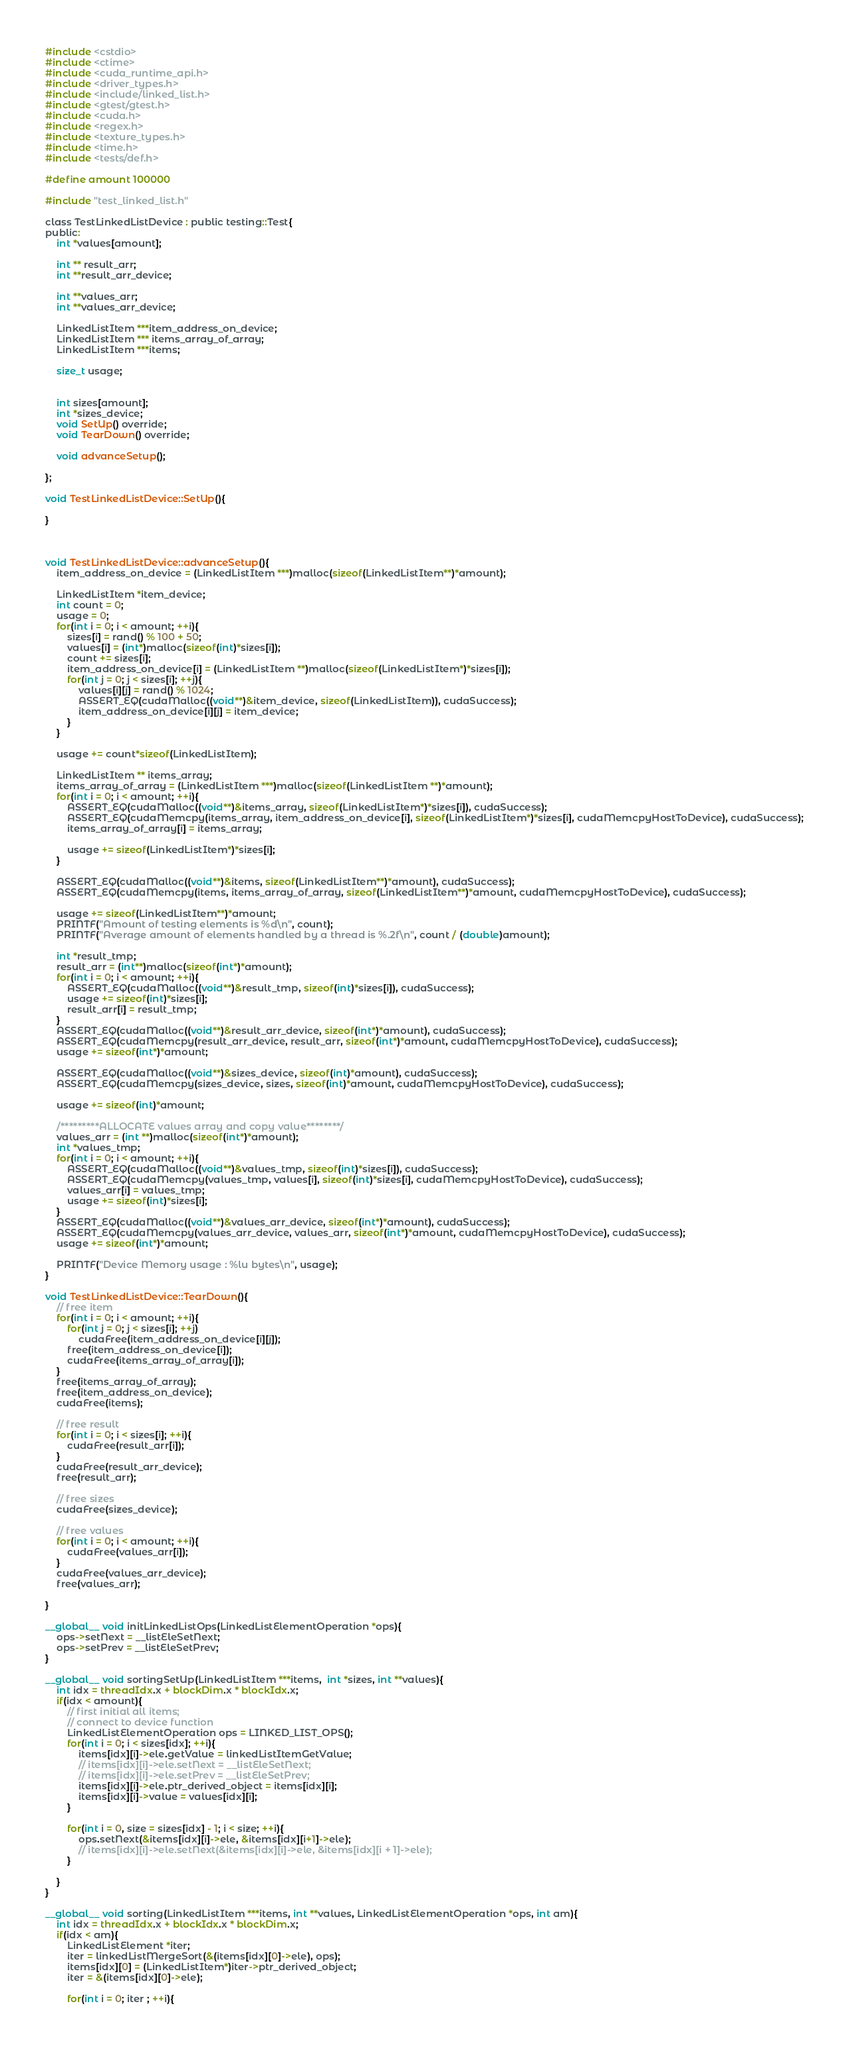<code> <loc_0><loc_0><loc_500><loc_500><_Cuda_>#include <cstdio>
#include <ctime>
#include <cuda_runtime_api.h>
#include <driver_types.h>
#include <include/linked_list.h>
#include <gtest/gtest.h>
#include <cuda.h>
#include <regex.h>
#include <texture_types.h>
#include <time.h>
#include <tests/def.h>

#define amount 100000

#include "test_linked_list.h"

class TestLinkedListDevice : public testing::Test{
public:
	int *values[amount];

	int ** result_arr;
	int **result_arr_device;

	int **values_arr;
	int **values_arr_device;

	LinkedListItem ***item_address_on_device;
	LinkedListItem *** items_array_of_array;
	LinkedListItem ***items;

	size_t usage;


	int sizes[amount];
	int *sizes_device;
	void SetUp() override;
	void TearDown() override;

	void advanceSetup();

};

void TestLinkedListDevice::SetUp(){

}



void TestLinkedListDevice::advanceSetup(){
	item_address_on_device = (LinkedListItem ***)malloc(sizeof(LinkedListItem**)*amount);	

	LinkedListItem *item_device;
	int count = 0;
	usage = 0;
	for(int i = 0; i < amount; ++i){
		sizes[i] = rand() % 100 + 50;
		values[i] = (int*)malloc(sizeof(int)*sizes[i]);
		count += sizes[i];
		item_address_on_device[i] = (LinkedListItem **)malloc(sizeof(LinkedListItem*)*sizes[i]);
		for(int j = 0; j < sizes[i]; ++j){
			values[i][j] = rand() % 1024;
			ASSERT_EQ(cudaMalloc((void**)&item_device, sizeof(LinkedListItem)), cudaSuccess);
			item_address_on_device[i][j] = item_device;
		}
	}
	
	usage += count*sizeof(LinkedListItem);
	
	LinkedListItem ** items_array;
	items_array_of_array = (LinkedListItem ***)malloc(sizeof(LinkedListItem **)*amount);
	for(int i = 0; i < amount; ++i){
		ASSERT_EQ(cudaMalloc((void**)&items_array, sizeof(LinkedListItem*)*sizes[i]), cudaSuccess);
		ASSERT_EQ(cudaMemcpy(items_array, item_address_on_device[i], sizeof(LinkedListItem*)*sizes[i], cudaMemcpyHostToDevice), cudaSuccess);
		items_array_of_array[i] = items_array;

		usage += sizeof(LinkedListItem*)*sizes[i];
	}

	ASSERT_EQ(cudaMalloc((void**)&items, sizeof(LinkedListItem**)*amount), cudaSuccess);
	ASSERT_EQ(cudaMemcpy(items, items_array_of_array, sizeof(LinkedListItem**)*amount, cudaMemcpyHostToDevice), cudaSuccess);

	usage += sizeof(LinkedListItem**)*amount;
	PRINTF("Amount of testing elements is %d\n", count);
	PRINTF("Average amount of elements handled by a thread is %.2f\n", count / (double)amount);

	int *result_tmp;
	result_arr = (int**)malloc(sizeof(int*)*amount);
	for(int i = 0; i < amount; ++i){
		ASSERT_EQ(cudaMalloc((void**)&result_tmp, sizeof(int)*sizes[i]), cudaSuccess);
		usage += sizeof(int)*sizes[i];
		result_arr[i] = result_tmp;
	}
	ASSERT_EQ(cudaMalloc((void**)&result_arr_device, sizeof(int*)*amount), cudaSuccess);
	ASSERT_EQ(cudaMemcpy(result_arr_device, result_arr, sizeof(int*)*amount, cudaMemcpyHostToDevice), cudaSuccess);
	usage += sizeof(int*)*amount;

	ASSERT_EQ(cudaMalloc((void**)&sizes_device, sizeof(int)*amount), cudaSuccess);
	ASSERT_EQ(cudaMemcpy(sizes_device, sizes, sizeof(int)*amount, cudaMemcpyHostToDevice), cudaSuccess);
	
	usage += sizeof(int)*amount;

	/*********ALLOCATE values array and copy value********/
	values_arr = (int **)malloc(sizeof(int*)*amount);
	int *values_tmp;
	for(int i = 0; i < amount; ++i){
		ASSERT_EQ(cudaMalloc((void**)&values_tmp, sizeof(int)*sizes[i]), cudaSuccess);
		ASSERT_EQ(cudaMemcpy(values_tmp, values[i], sizeof(int)*sizes[i], cudaMemcpyHostToDevice), cudaSuccess);
		values_arr[i] = values_tmp;
		usage += sizeof(int)*sizes[i];
	}
	ASSERT_EQ(cudaMalloc((void**)&values_arr_device, sizeof(int*)*amount), cudaSuccess);
	ASSERT_EQ(cudaMemcpy(values_arr_device, values_arr, sizeof(int*)*amount, cudaMemcpyHostToDevice), cudaSuccess);
	usage += sizeof(int*)*amount;

	PRINTF("Device Memory usage : %lu bytes\n", usage);
}

void TestLinkedListDevice::TearDown(){
	// free item
	for(int i = 0; i < amount; ++i){
		for(int j = 0; j < sizes[i]; ++j)
			cudaFree(item_address_on_device[i][j]);
		free(item_address_on_device[i]);
		cudaFree(items_array_of_array[i]);
	}
	free(items_array_of_array);
	free(item_address_on_device);
	cudaFree(items);

	// free result
	for(int i = 0; i < sizes[i]; ++i){
		cudaFree(result_arr[i]);
	}
	cudaFree(result_arr_device);
	free(result_arr);

	// free sizes
	cudaFree(sizes_device);

	// free values
	for(int i = 0; i < amount; ++i){
		cudaFree(values_arr[i]);
	}
	cudaFree(values_arr_device);
	free(values_arr);
	
}

__global__ void initLinkedListOps(LinkedListElementOperation *ops){
	ops->setNext = __listEleSetNext;
	ops->setPrev = __listEleSetPrev;
}

__global__ void sortingSetUp(LinkedListItem ***items,  int *sizes, int **values){
	int idx = threadIdx.x + blockDim.x * blockIdx.x;
	if(idx < amount){
		// first initial all items;
		// connect to device function
		LinkedListElementOperation ops = LINKED_LIST_OPS();
		for(int i = 0; i < sizes[idx]; ++i){
			items[idx][i]->ele.getValue = linkedListItemGetValue;
			// items[idx][i]->ele.setNext = __listEleSetNext;
			// items[idx][i]->ele.setPrev = __listEleSetPrev;
			items[idx][i]->ele.ptr_derived_object = items[idx][i];
			items[idx][i]->value = values[idx][i];
		}

		for(int i = 0, size = sizes[idx] - 1; i < size; ++i){
			ops.setNext(&items[idx][i]->ele, &items[idx][i+1]->ele);		
			// items[idx][i]->ele.setNext(&items[idx][i]->ele, &items[idx][i + 1]->ele);
		}

	}
}

__global__ void sorting(LinkedListItem ***items, int **values, LinkedListElementOperation *ops, int am){
 	int idx = threadIdx.x + blockIdx.x * blockDim.x;
 	if(idx < am){
		LinkedListElement *iter;
 		iter = linkedListMergeSort(&(items[idx][0]->ele), ops);
		items[idx][0] = (LinkedListItem*)iter->ptr_derived_object;
		iter = &(items[idx][0]->ele);

		for(int i = 0; iter ; ++i){</code> 